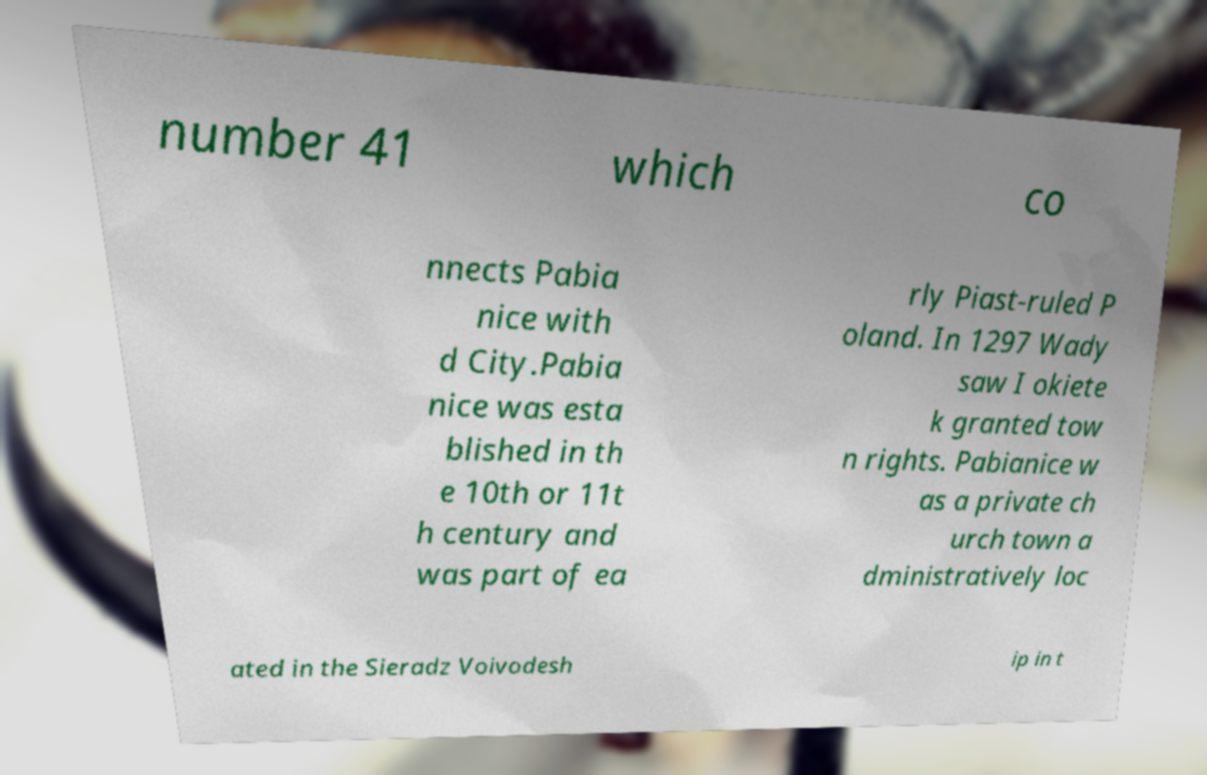Please read and relay the text visible in this image. What does it say? number 41 which co nnects Pabia nice with d City.Pabia nice was esta blished in th e 10th or 11t h century and was part of ea rly Piast-ruled P oland. In 1297 Wady saw I okiete k granted tow n rights. Pabianice w as a private ch urch town a dministratively loc ated in the Sieradz Voivodesh ip in t 